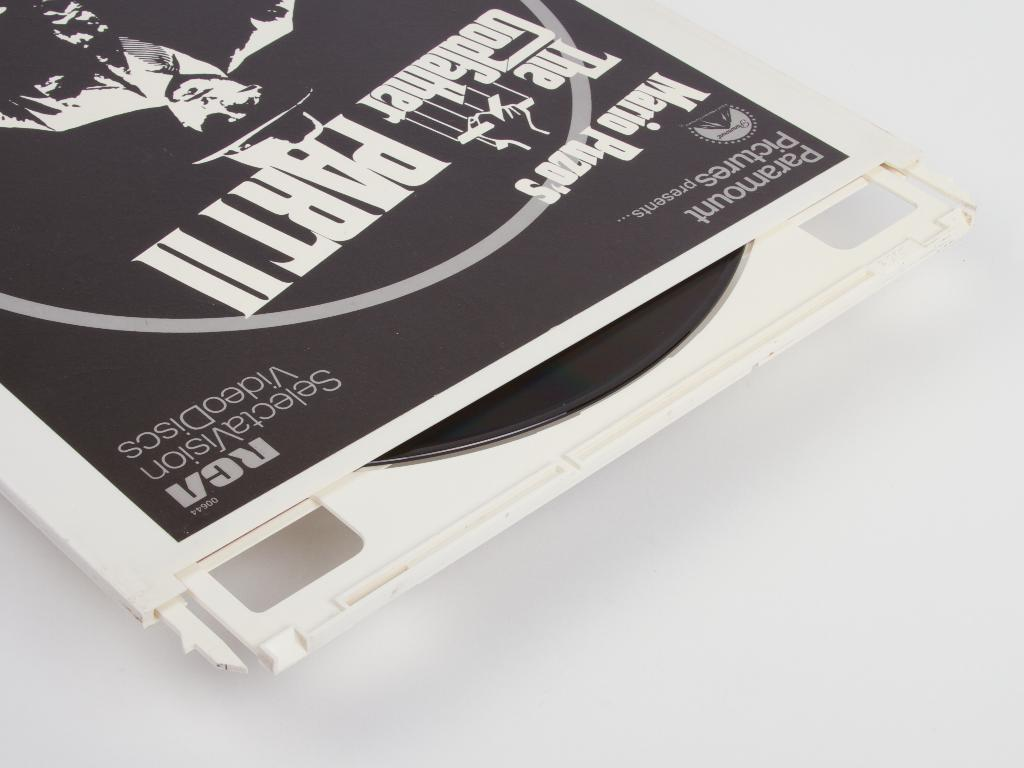What is the main object in the image? There is a CD box in the image. What is inside the CD box? There is a CD in the image. Where are the CD and CD box located? The CD and CD box are on a white surface. What can be seen on the CD box? There is an image on the CD box. What information is provided on the CD box? There is writing on the CD box. Can you see any fog in the image? There is no fog present in the image. Is there a secretary working at a desk in the image? There is no secretary or desk present in the image. 